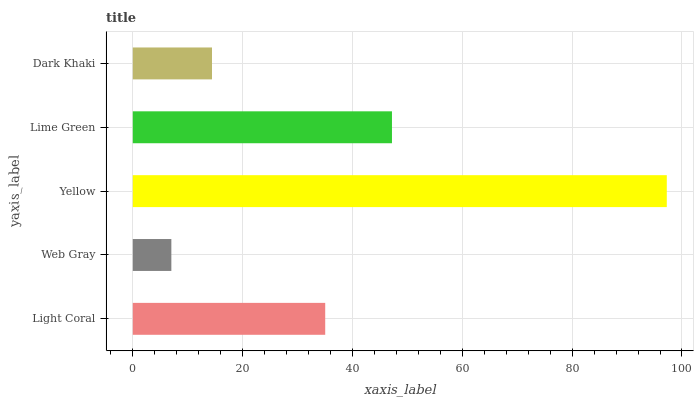Is Web Gray the minimum?
Answer yes or no. Yes. Is Yellow the maximum?
Answer yes or no. Yes. Is Yellow the minimum?
Answer yes or no. No. Is Web Gray the maximum?
Answer yes or no. No. Is Yellow greater than Web Gray?
Answer yes or no. Yes. Is Web Gray less than Yellow?
Answer yes or no. Yes. Is Web Gray greater than Yellow?
Answer yes or no. No. Is Yellow less than Web Gray?
Answer yes or no. No. Is Light Coral the high median?
Answer yes or no. Yes. Is Light Coral the low median?
Answer yes or no. Yes. Is Web Gray the high median?
Answer yes or no. No. Is Dark Khaki the low median?
Answer yes or no. No. 